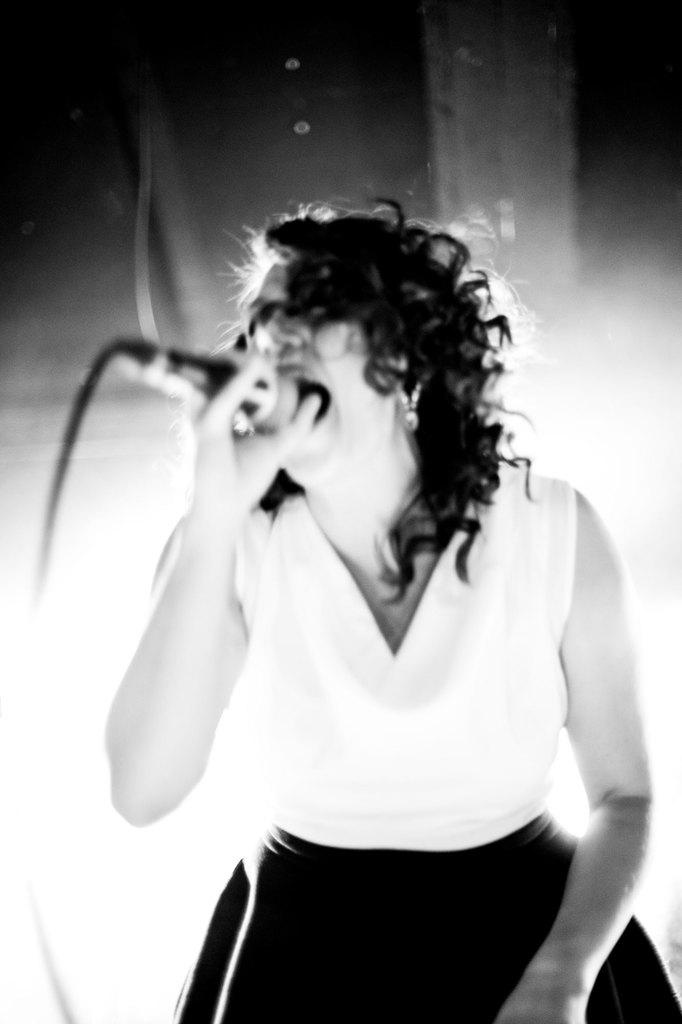Who is the main subject in the image? There is a woman in the image. What is the woman doing in the image? The woman is standing and singing. What object is present in the image that is related to the woman's activity? There is a mic in the image. What type of pear is hanging from the mic in the image? There is no pear present in the image; it only features a woman singing with a mic. 